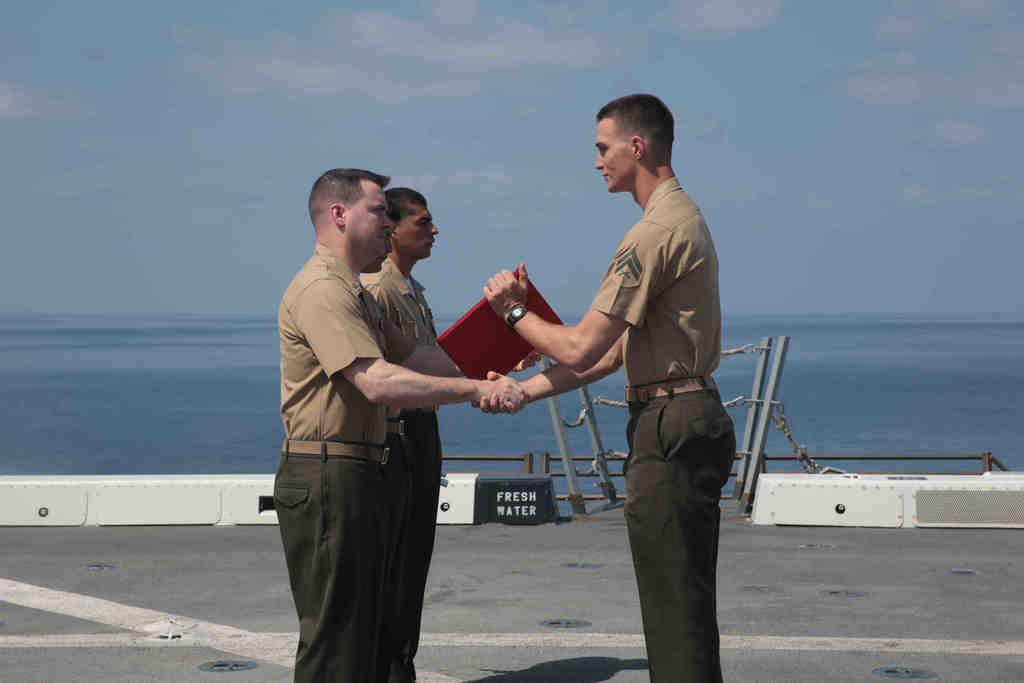How many people are in the image? There are three persons in the image. What are the persons holding in the image? The persons are holding a red object. What can be seen in the background of the image? There is water and a white and black board visible in the background. What other objects are present in the image? There are poles and chains in the image. What is the color of the sky in the image? The sky is blue and white in color. What letters are written on the ring in the image? There is no ring present in the image, so it is not possible to determine what letters might be written on it. 